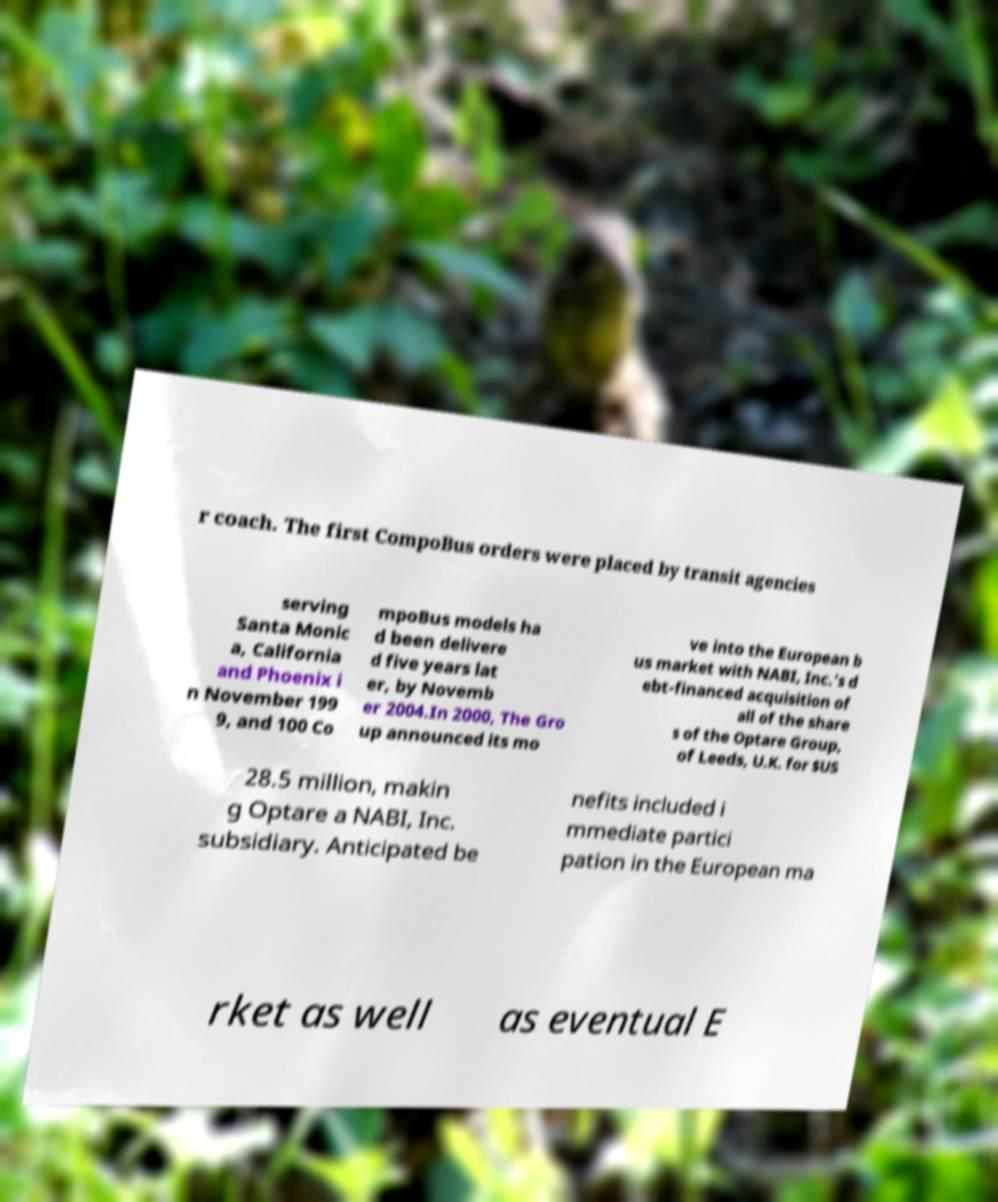Could you extract and type out the text from this image? r coach. The first CompoBus orders were placed by transit agencies serving Santa Monic a, California and Phoenix i n November 199 9, and 100 Co mpoBus models ha d been delivere d five years lat er, by Novemb er 2004.In 2000, The Gro up announced its mo ve into the European b us market with NABI, Inc.'s d ebt-financed acquisition of all of the share s of the Optare Group, of Leeds, U.K. for $US 28.5 million, makin g Optare a NABI, Inc. subsidiary. Anticipated be nefits included i mmediate partici pation in the European ma rket as well as eventual E 